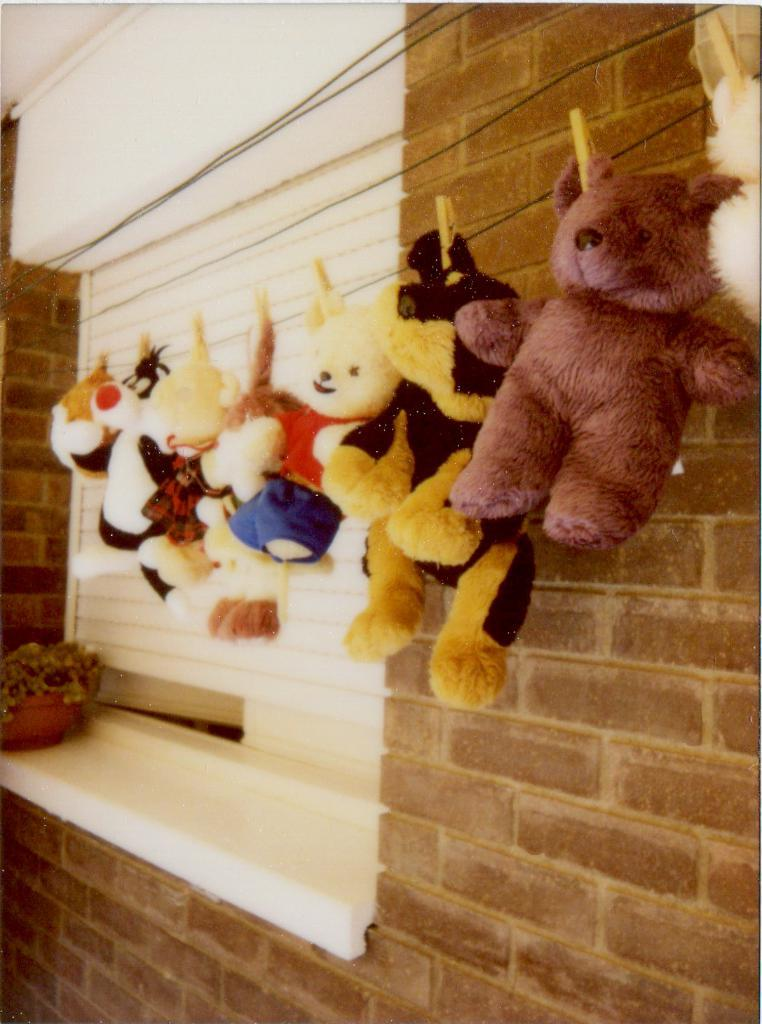What is hanging from the wire in the image? There are toys hanging from a wire in the image. What can be observed about the toys in terms of color? The toys are in multiple colors. What type of vegetation is present in the image? There is a small plant in the image. What is the color of the plant? The plant is green. What is the color of the wall in the image? The wall is brown. Is the queen present in the image? There is no queen depicted in the image. Can you see any rats in the image? There are no rats present in the image. 